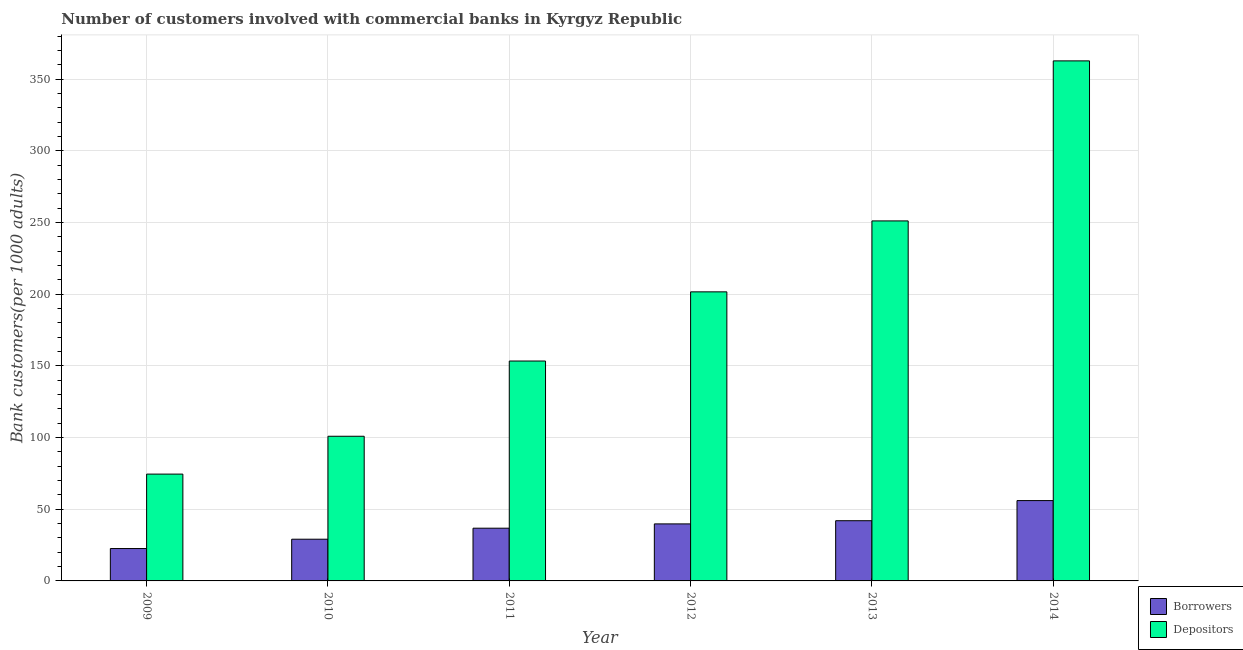How many different coloured bars are there?
Your answer should be compact. 2. How many groups of bars are there?
Keep it short and to the point. 6. Are the number of bars per tick equal to the number of legend labels?
Provide a succinct answer. Yes. Are the number of bars on each tick of the X-axis equal?
Make the answer very short. Yes. How many bars are there on the 2nd tick from the left?
Make the answer very short. 2. How many bars are there on the 3rd tick from the right?
Make the answer very short. 2. In how many cases, is the number of bars for a given year not equal to the number of legend labels?
Provide a short and direct response. 0. What is the number of borrowers in 2010?
Give a very brief answer. 29.09. Across all years, what is the maximum number of borrowers?
Make the answer very short. 56.04. Across all years, what is the minimum number of borrowers?
Offer a very short reply. 22.59. In which year was the number of depositors maximum?
Provide a succinct answer. 2014. In which year was the number of depositors minimum?
Ensure brevity in your answer.  2009. What is the total number of borrowers in the graph?
Offer a very short reply. 226.28. What is the difference between the number of borrowers in 2010 and that in 2014?
Keep it short and to the point. -26.95. What is the difference between the number of borrowers in 2012 and the number of depositors in 2010?
Provide a succinct answer. 10.69. What is the average number of borrowers per year?
Give a very brief answer. 37.71. In how many years, is the number of borrowers greater than 100?
Your answer should be very brief. 0. What is the ratio of the number of depositors in 2013 to that in 2014?
Give a very brief answer. 0.69. Is the number of borrowers in 2010 less than that in 2013?
Offer a terse response. Yes. What is the difference between the highest and the second highest number of borrowers?
Offer a very short reply. 14.04. What is the difference between the highest and the lowest number of borrowers?
Make the answer very short. 33.45. What does the 2nd bar from the left in 2013 represents?
Provide a short and direct response. Depositors. What does the 1st bar from the right in 2010 represents?
Give a very brief answer. Depositors. Are all the bars in the graph horizontal?
Ensure brevity in your answer.  No. What is the difference between two consecutive major ticks on the Y-axis?
Your answer should be compact. 50. Does the graph contain any zero values?
Provide a succinct answer. No. Where does the legend appear in the graph?
Your response must be concise. Bottom right. How many legend labels are there?
Your response must be concise. 2. What is the title of the graph?
Provide a short and direct response. Number of customers involved with commercial banks in Kyrgyz Republic. What is the label or title of the Y-axis?
Offer a very short reply. Bank customers(per 1000 adults). What is the Bank customers(per 1000 adults) in Borrowers in 2009?
Ensure brevity in your answer.  22.59. What is the Bank customers(per 1000 adults) in Depositors in 2009?
Ensure brevity in your answer.  74.51. What is the Bank customers(per 1000 adults) in Borrowers in 2010?
Your answer should be very brief. 29.09. What is the Bank customers(per 1000 adults) in Depositors in 2010?
Give a very brief answer. 100.91. What is the Bank customers(per 1000 adults) of Borrowers in 2011?
Your answer should be compact. 36.78. What is the Bank customers(per 1000 adults) of Depositors in 2011?
Offer a terse response. 153.38. What is the Bank customers(per 1000 adults) in Borrowers in 2012?
Your response must be concise. 39.78. What is the Bank customers(per 1000 adults) of Depositors in 2012?
Provide a succinct answer. 201.64. What is the Bank customers(per 1000 adults) in Borrowers in 2013?
Ensure brevity in your answer.  42. What is the Bank customers(per 1000 adults) in Depositors in 2013?
Your answer should be compact. 251.12. What is the Bank customers(per 1000 adults) in Borrowers in 2014?
Your answer should be compact. 56.04. What is the Bank customers(per 1000 adults) in Depositors in 2014?
Your response must be concise. 362.74. Across all years, what is the maximum Bank customers(per 1000 adults) in Borrowers?
Your response must be concise. 56.04. Across all years, what is the maximum Bank customers(per 1000 adults) in Depositors?
Make the answer very short. 362.74. Across all years, what is the minimum Bank customers(per 1000 adults) of Borrowers?
Give a very brief answer. 22.59. Across all years, what is the minimum Bank customers(per 1000 adults) in Depositors?
Give a very brief answer. 74.51. What is the total Bank customers(per 1000 adults) of Borrowers in the graph?
Keep it short and to the point. 226.28. What is the total Bank customers(per 1000 adults) in Depositors in the graph?
Offer a terse response. 1144.3. What is the difference between the Bank customers(per 1000 adults) in Borrowers in 2009 and that in 2010?
Ensure brevity in your answer.  -6.5. What is the difference between the Bank customers(per 1000 adults) of Depositors in 2009 and that in 2010?
Make the answer very short. -26.4. What is the difference between the Bank customers(per 1000 adults) of Borrowers in 2009 and that in 2011?
Offer a very short reply. -14.19. What is the difference between the Bank customers(per 1000 adults) of Depositors in 2009 and that in 2011?
Your answer should be compact. -78.87. What is the difference between the Bank customers(per 1000 adults) of Borrowers in 2009 and that in 2012?
Your answer should be compact. -17.19. What is the difference between the Bank customers(per 1000 adults) in Depositors in 2009 and that in 2012?
Your answer should be compact. -127.13. What is the difference between the Bank customers(per 1000 adults) in Borrowers in 2009 and that in 2013?
Your answer should be compact. -19.41. What is the difference between the Bank customers(per 1000 adults) of Depositors in 2009 and that in 2013?
Make the answer very short. -176.61. What is the difference between the Bank customers(per 1000 adults) of Borrowers in 2009 and that in 2014?
Offer a very short reply. -33.45. What is the difference between the Bank customers(per 1000 adults) of Depositors in 2009 and that in 2014?
Your answer should be compact. -288.23. What is the difference between the Bank customers(per 1000 adults) in Borrowers in 2010 and that in 2011?
Ensure brevity in your answer.  -7.68. What is the difference between the Bank customers(per 1000 adults) of Depositors in 2010 and that in 2011?
Ensure brevity in your answer.  -52.48. What is the difference between the Bank customers(per 1000 adults) of Borrowers in 2010 and that in 2012?
Offer a terse response. -10.69. What is the difference between the Bank customers(per 1000 adults) in Depositors in 2010 and that in 2012?
Provide a short and direct response. -100.73. What is the difference between the Bank customers(per 1000 adults) in Borrowers in 2010 and that in 2013?
Ensure brevity in your answer.  -12.9. What is the difference between the Bank customers(per 1000 adults) of Depositors in 2010 and that in 2013?
Keep it short and to the point. -150.21. What is the difference between the Bank customers(per 1000 adults) of Borrowers in 2010 and that in 2014?
Offer a terse response. -26.95. What is the difference between the Bank customers(per 1000 adults) in Depositors in 2010 and that in 2014?
Offer a very short reply. -261.84. What is the difference between the Bank customers(per 1000 adults) in Borrowers in 2011 and that in 2012?
Offer a terse response. -3. What is the difference between the Bank customers(per 1000 adults) in Depositors in 2011 and that in 2012?
Your answer should be compact. -48.25. What is the difference between the Bank customers(per 1000 adults) of Borrowers in 2011 and that in 2013?
Give a very brief answer. -5.22. What is the difference between the Bank customers(per 1000 adults) of Depositors in 2011 and that in 2013?
Keep it short and to the point. -97.73. What is the difference between the Bank customers(per 1000 adults) in Borrowers in 2011 and that in 2014?
Your answer should be very brief. -19.26. What is the difference between the Bank customers(per 1000 adults) of Depositors in 2011 and that in 2014?
Your response must be concise. -209.36. What is the difference between the Bank customers(per 1000 adults) of Borrowers in 2012 and that in 2013?
Offer a very short reply. -2.22. What is the difference between the Bank customers(per 1000 adults) in Depositors in 2012 and that in 2013?
Make the answer very short. -49.48. What is the difference between the Bank customers(per 1000 adults) in Borrowers in 2012 and that in 2014?
Keep it short and to the point. -16.26. What is the difference between the Bank customers(per 1000 adults) in Depositors in 2012 and that in 2014?
Give a very brief answer. -161.11. What is the difference between the Bank customers(per 1000 adults) of Borrowers in 2013 and that in 2014?
Give a very brief answer. -14.04. What is the difference between the Bank customers(per 1000 adults) in Depositors in 2013 and that in 2014?
Give a very brief answer. -111.63. What is the difference between the Bank customers(per 1000 adults) in Borrowers in 2009 and the Bank customers(per 1000 adults) in Depositors in 2010?
Your answer should be very brief. -78.32. What is the difference between the Bank customers(per 1000 adults) of Borrowers in 2009 and the Bank customers(per 1000 adults) of Depositors in 2011?
Offer a very short reply. -130.79. What is the difference between the Bank customers(per 1000 adults) of Borrowers in 2009 and the Bank customers(per 1000 adults) of Depositors in 2012?
Offer a terse response. -179.05. What is the difference between the Bank customers(per 1000 adults) in Borrowers in 2009 and the Bank customers(per 1000 adults) in Depositors in 2013?
Keep it short and to the point. -228.53. What is the difference between the Bank customers(per 1000 adults) in Borrowers in 2009 and the Bank customers(per 1000 adults) in Depositors in 2014?
Keep it short and to the point. -340.15. What is the difference between the Bank customers(per 1000 adults) in Borrowers in 2010 and the Bank customers(per 1000 adults) in Depositors in 2011?
Keep it short and to the point. -124.29. What is the difference between the Bank customers(per 1000 adults) of Borrowers in 2010 and the Bank customers(per 1000 adults) of Depositors in 2012?
Your answer should be very brief. -172.54. What is the difference between the Bank customers(per 1000 adults) of Borrowers in 2010 and the Bank customers(per 1000 adults) of Depositors in 2013?
Offer a terse response. -222.02. What is the difference between the Bank customers(per 1000 adults) of Borrowers in 2010 and the Bank customers(per 1000 adults) of Depositors in 2014?
Ensure brevity in your answer.  -333.65. What is the difference between the Bank customers(per 1000 adults) in Borrowers in 2011 and the Bank customers(per 1000 adults) in Depositors in 2012?
Keep it short and to the point. -164.86. What is the difference between the Bank customers(per 1000 adults) of Borrowers in 2011 and the Bank customers(per 1000 adults) of Depositors in 2013?
Offer a terse response. -214.34. What is the difference between the Bank customers(per 1000 adults) in Borrowers in 2011 and the Bank customers(per 1000 adults) in Depositors in 2014?
Make the answer very short. -325.97. What is the difference between the Bank customers(per 1000 adults) of Borrowers in 2012 and the Bank customers(per 1000 adults) of Depositors in 2013?
Make the answer very short. -211.34. What is the difference between the Bank customers(per 1000 adults) of Borrowers in 2012 and the Bank customers(per 1000 adults) of Depositors in 2014?
Offer a very short reply. -322.96. What is the difference between the Bank customers(per 1000 adults) in Borrowers in 2013 and the Bank customers(per 1000 adults) in Depositors in 2014?
Keep it short and to the point. -320.75. What is the average Bank customers(per 1000 adults) of Borrowers per year?
Offer a terse response. 37.71. What is the average Bank customers(per 1000 adults) of Depositors per year?
Offer a very short reply. 190.72. In the year 2009, what is the difference between the Bank customers(per 1000 adults) in Borrowers and Bank customers(per 1000 adults) in Depositors?
Your response must be concise. -51.92. In the year 2010, what is the difference between the Bank customers(per 1000 adults) in Borrowers and Bank customers(per 1000 adults) in Depositors?
Your answer should be very brief. -71.81. In the year 2011, what is the difference between the Bank customers(per 1000 adults) of Borrowers and Bank customers(per 1000 adults) of Depositors?
Your answer should be very brief. -116.61. In the year 2012, what is the difference between the Bank customers(per 1000 adults) of Borrowers and Bank customers(per 1000 adults) of Depositors?
Ensure brevity in your answer.  -161.86. In the year 2013, what is the difference between the Bank customers(per 1000 adults) of Borrowers and Bank customers(per 1000 adults) of Depositors?
Your answer should be very brief. -209.12. In the year 2014, what is the difference between the Bank customers(per 1000 adults) in Borrowers and Bank customers(per 1000 adults) in Depositors?
Ensure brevity in your answer.  -306.7. What is the ratio of the Bank customers(per 1000 adults) in Borrowers in 2009 to that in 2010?
Give a very brief answer. 0.78. What is the ratio of the Bank customers(per 1000 adults) of Depositors in 2009 to that in 2010?
Offer a terse response. 0.74. What is the ratio of the Bank customers(per 1000 adults) of Borrowers in 2009 to that in 2011?
Your answer should be very brief. 0.61. What is the ratio of the Bank customers(per 1000 adults) in Depositors in 2009 to that in 2011?
Your answer should be very brief. 0.49. What is the ratio of the Bank customers(per 1000 adults) of Borrowers in 2009 to that in 2012?
Ensure brevity in your answer.  0.57. What is the ratio of the Bank customers(per 1000 adults) of Depositors in 2009 to that in 2012?
Provide a short and direct response. 0.37. What is the ratio of the Bank customers(per 1000 adults) in Borrowers in 2009 to that in 2013?
Offer a terse response. 0.54. What is the ratio of the Bank customers(per 1000 adults) of Depositors in 2009 to that in 2013?
Your answer should be very brief. 0.3. What is the ratio of the Bank customers(per 1000 adults) of Borrowers in 2009 to that in 2014?
Make the answer very short. 0.4. What is the ratio of the Bank customers(per 1000 adults) of Depositors in 2009 to that in 2014?
Give a very brief answer. 0.21. What is the ratio of the Bank customers(per 1000 adults) in Borrowers in 2010 to that in 2011?
Offer a terse response. 0.79. What is the ratio of the Bank customers(per 1000 adults) in Depositors in 2010 to that in 2011?
Keep it short and to the point. 0.66. What is the ratio of the Bank customers(per 1000 adults) in Borrowers in 2010 to that in 2012?
Offer a very short reply. 0.73. What is the ratio of the Bank customers(per 1000 adults) in Depositors in 2010 to that in 2012?
Your answer should be very brief. 0.5. What is the ratio of the Bank customers(per 1000 adults) of Borrowers in 2010 to that in 2013?
Your answer should be compact. 0.69. What is the ratio of the Bank customers(per 1000 adults) of Depositors in 2010 to that in 2013?
Ensure brevity in your answer.  0.4. What is the ratio of the Bank customers(per 1000 adults) of Borrowers in 2010 to that in 2014?
Your response must be concise. 0.52. What is the ratio of the Bank customers(per 1000 adults) in Depositors in 2010 to that in 2014?
Keep it short and to the point. 0.28. What is the ratio of the Bank customers(per 1000 adults) of Borrowers in 2011 to that in 2012?
Give a very brief answer. 0.92. What is the ratio of the Bank customers(per 1000 adults) in Depositors in 2011 to that in 2012?
Give a very brief answer. 0.76. What is the ratio of the Bank customers(per 1000 adults) in Borrowers in 2011 to that in 2013?
Your answer should be very brief. 0.88. What is the ratio of the Bank customers(per 1000 adults) in Depositors in 2011 to that in 2013?
Ensure brevity in your answer.  0.61. What is the ratio of the Bank customers(per 1000 adults) in Borrowers in 2011 to that in 2014?
Make the answer very short. 0.66. What is the ratio of the Bank customers(per 1000 adults) in Depositors in 2011 to that in 2014?
Make the answer very short. 0.42. What is the ratio of the Bank customers(per 1000 adults) of Borrowers in 2012 to that in 2013?
Ensure brevity in your answer.  0.95. What is the ratio of the Bank customers(per 1000 adults) in Depositors in 2012 to that in 2013?
Offer a terse response. 0.8. What is the ratio of the Bank customers(per 1000 adults) of Borrowers in 2012 to that in 2014?
Give a very brief answer. 0.71. What is the ratio of the Bank customers(per 1000 adults) of Depositors in 2012 to that in 2014?
Make the answer very short. 0.56. What is the ratio of the Bank customers(per 1000 adults) of Borrowers in 2013 to that in 2014?
Ensure brevity in your answer.  0.75. What is the ratio of the Bank customers(per 1000 adults) of Depositors in 2013 to that in 2014?
Ensure brevity in your answer.  0.69. What is the difference between the highest and the second highest Bank customers(per 1000 adults) in Borrowers?
Your answer should be compact. 14.04. What is the difference between the highest and the second highest Bank customers(per 1000 adults) of Depositors?
Provide a short and direct response. 111.63. What is the difference between the highest and the lowest Bank customers(per 1000 adults) of Borrowers?
Provide a succinct answer. 33.45. What is the difference between the highest and the lowest Bank customers(per 1000 adults) in Depositors?
Provide a short and direct response. 288.23. 